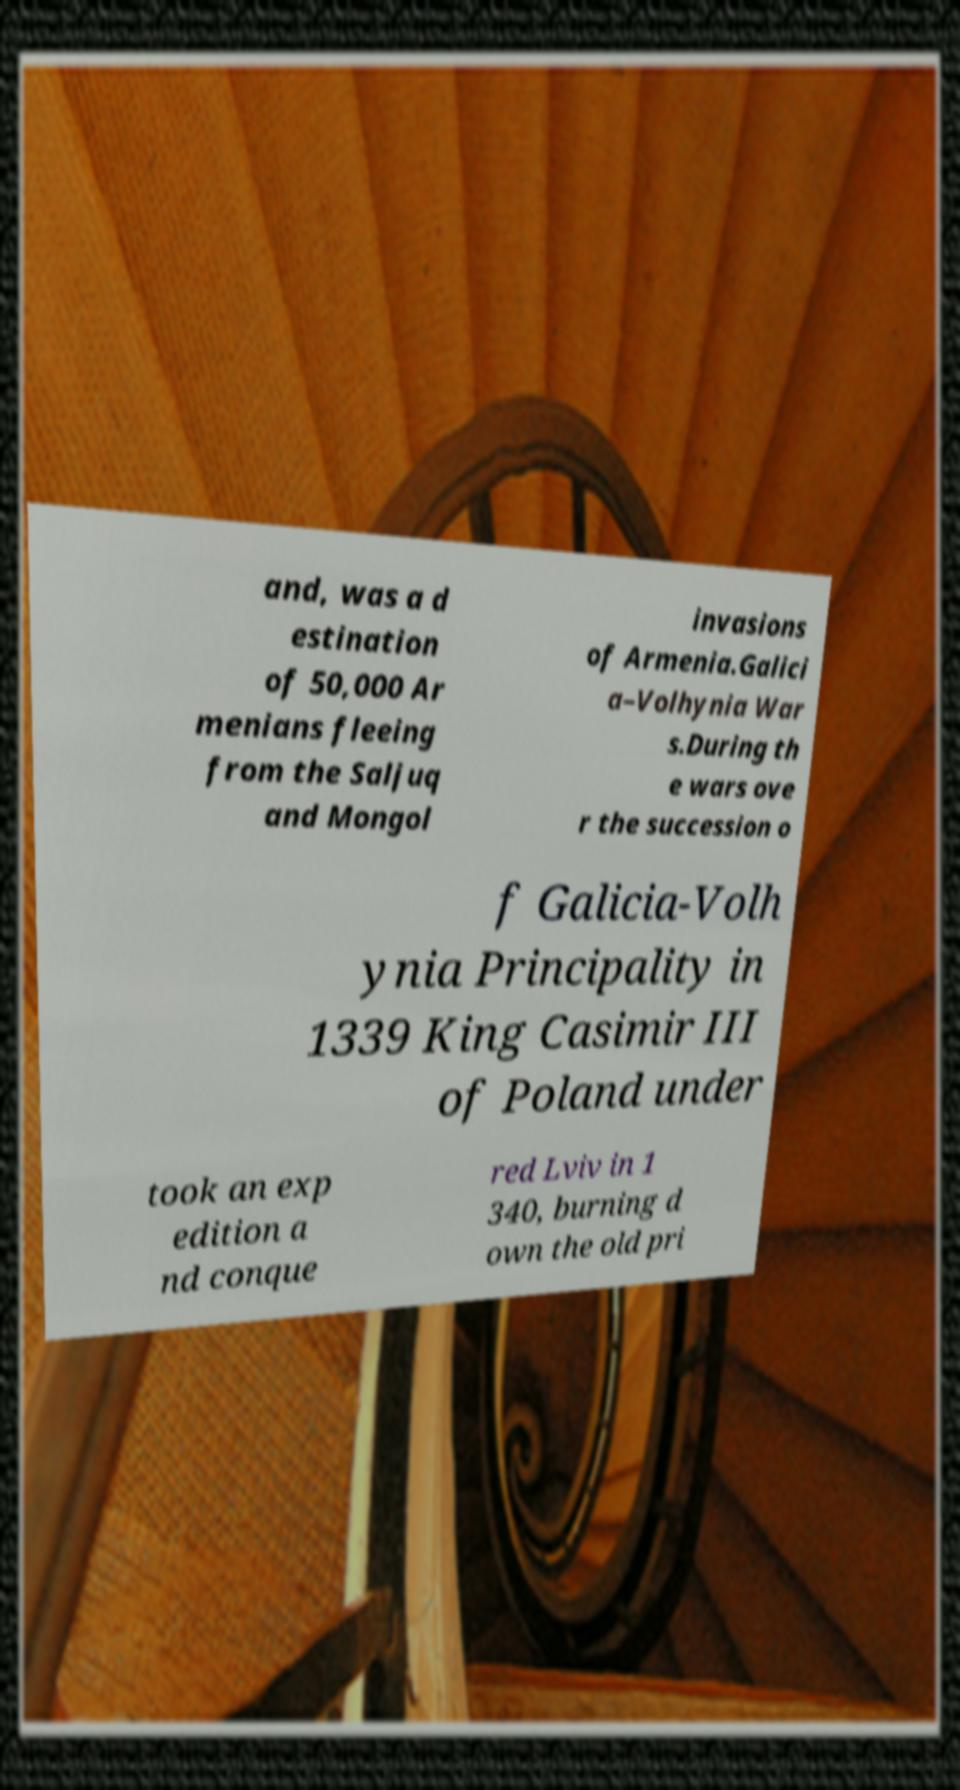There's text embedded in this image that I need extracted. Can you transcribe it verbatim? and, was a d estination of 50,000 Ar menians fleeing from the Saljuq and Mongol invasions of Armenia.Galici a–Volhynia War s.During th e wars ove r the succession o f Galicia-Volh ynia Principality in 1339 King Casimir III of Poland under took an exp edition a nd conque red Lviv in 1 340, burning d own the old pri 